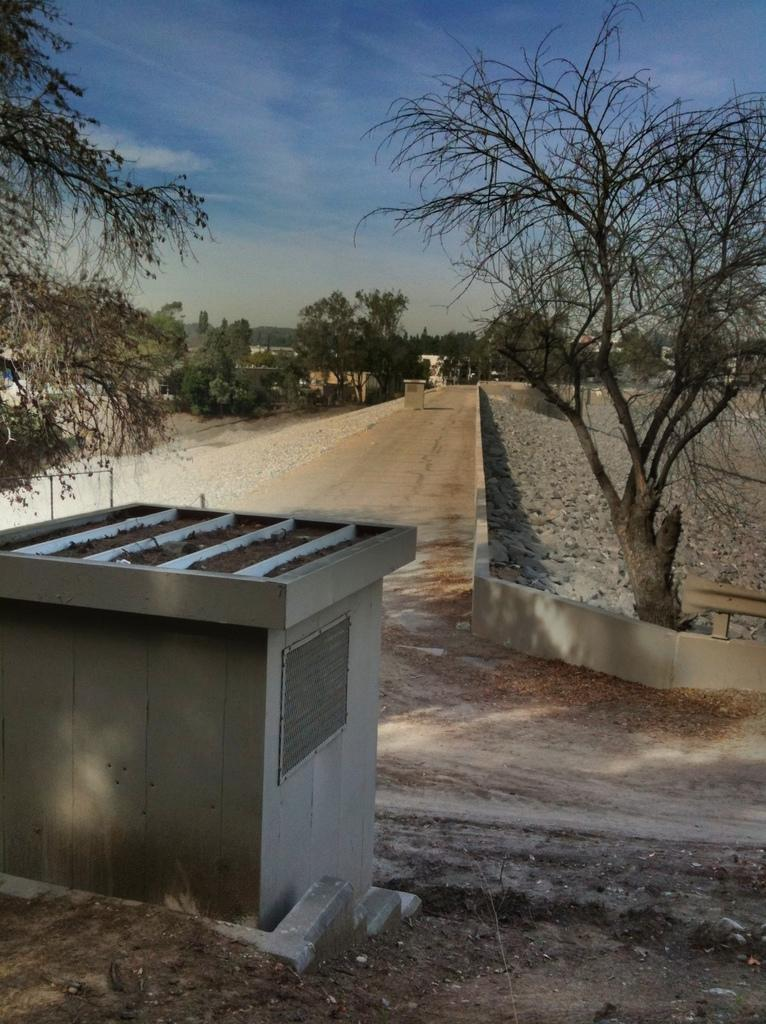What type of structure is present in the image? There is a cement box in the image. What natural elements can be seen in the image? There are trees in the image. What type of ground surface is visible in the image? There are stones in the image. What type of man-made structures are present in the image? There are buildings in the image. What is the color of the sky in the image? The sky is blue and white in color. Can you see any clovers growing near the cement box in the image? There are no clovers present in the image. What is the chin of the person in the image doing? There is no person present in the image, so there is no chin to describe. 